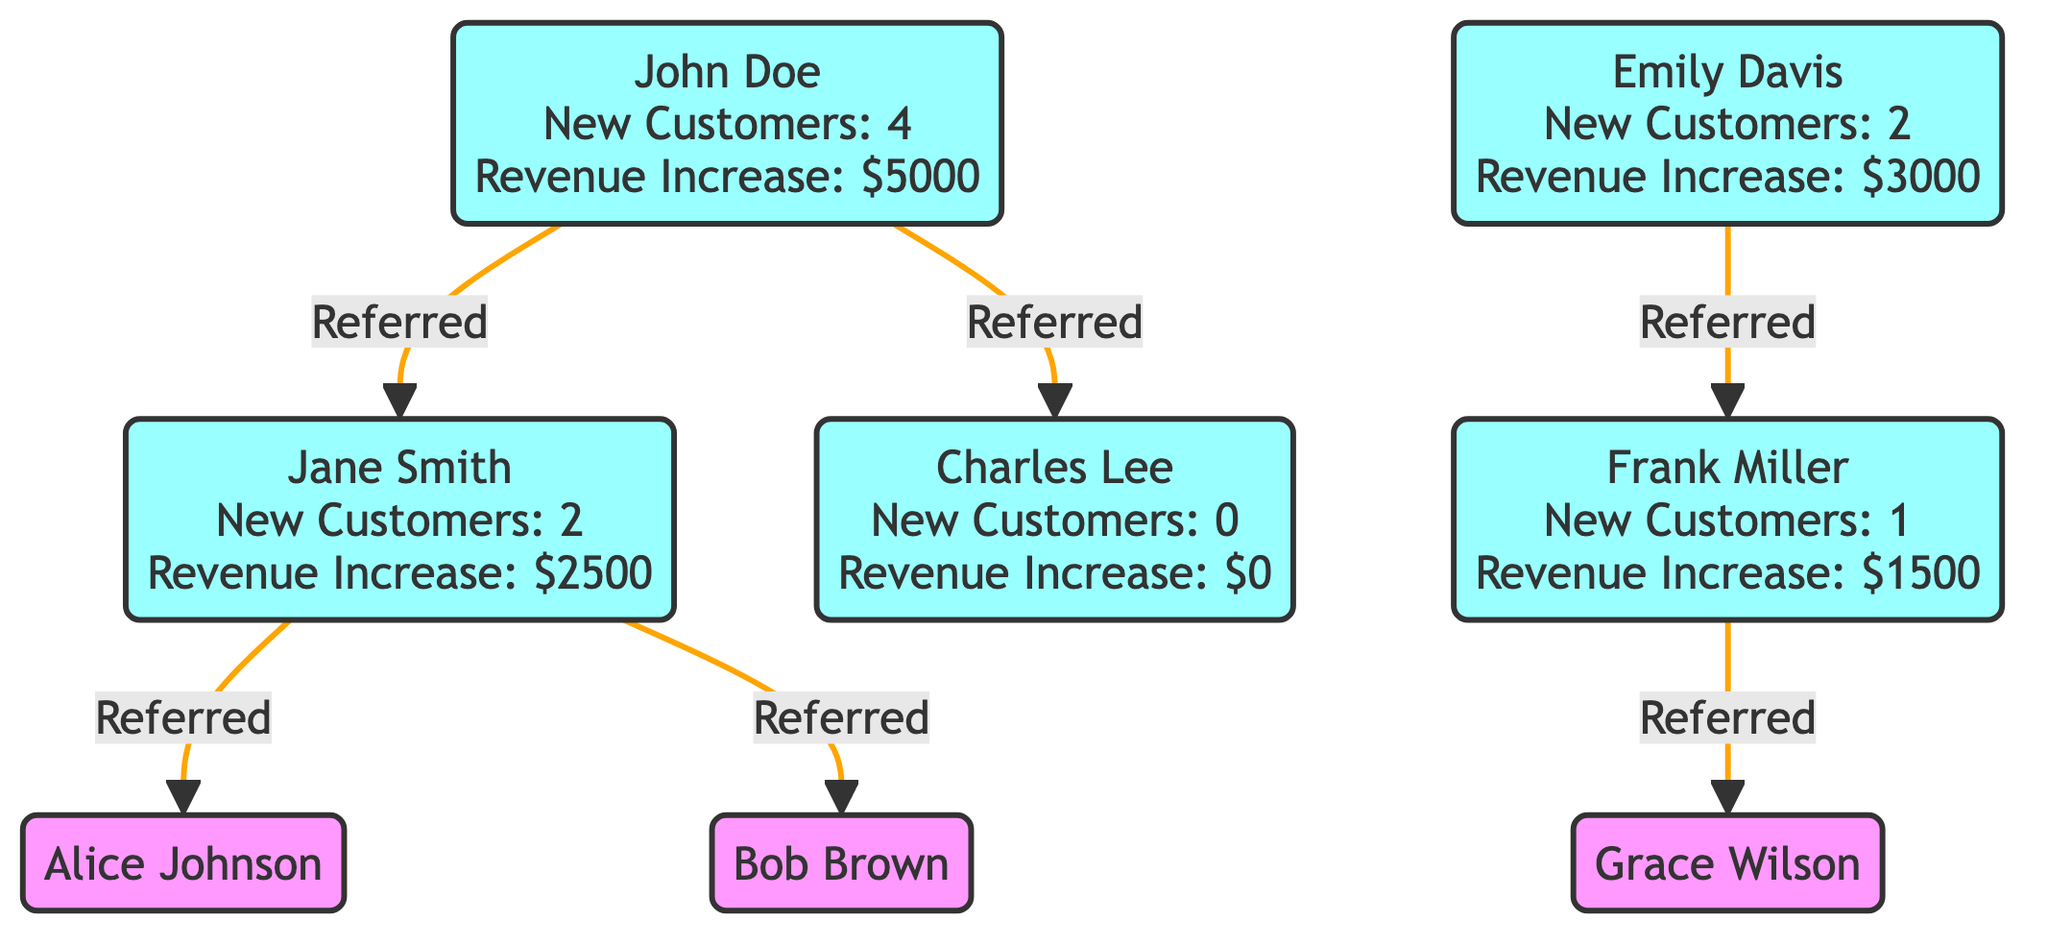What is the total number of referred customers for John Doe? John Doe has referred two customers: Jane Smith and Charles Lee. Thus, the total number of referred customers for John Doe is 2.
Answer: 2 How many new customers did Emily Davis bring? The diagram indicates that Emily Davis has contributed to bringing in 2 new customers.
Answer: 2 Which customer has the highest revenue increase? According to the diagram, John Doe has the highest revenue increase of 5000 dollars, more than any other customer.
Answer: 5000 What is the relationship between Jane Smith and Alice Johnson? Jane Smith is directly connected to Alice Johnson as a referred customer, indicating that Jane Smith referred Alice Johnson.
Answer: Referred How many total new customers were generated from all referrals? By aggregating the new customers from all referring individuals, John Doe (4) + Jane Smith (2) + Charles Lee (0) + Emily Davis (2) + Frank Miller (1) totals to 9 new customers.
Answer: 9 Who referred Grace Wilson? The diagram shows that Frank Miller is the individual who referred Grace Wilson, establishing a direct referral connection.
Answer: Frank Miller What is the total revenue increase contributed by Jane Smith and Emily Davis? By calculating the total revenue increase from Jane Smith (2500) and Emily Davis (3000), the overall increase can be summed as 2500 + 3000, which totals to 5500 dollars.
Answer: 5500 What is the revenue increase for Charles Lee? The diagram specifies that Charles Lee has a revenue increase of 0 dollars, indicating no financial impact from his referrals.
Answer: 0 How many customers are directly referred by John Doe? The diagram depicts that John Doe directly refers to two individuals, which are Jane Smith and Charles Lee.
Answer: 2 